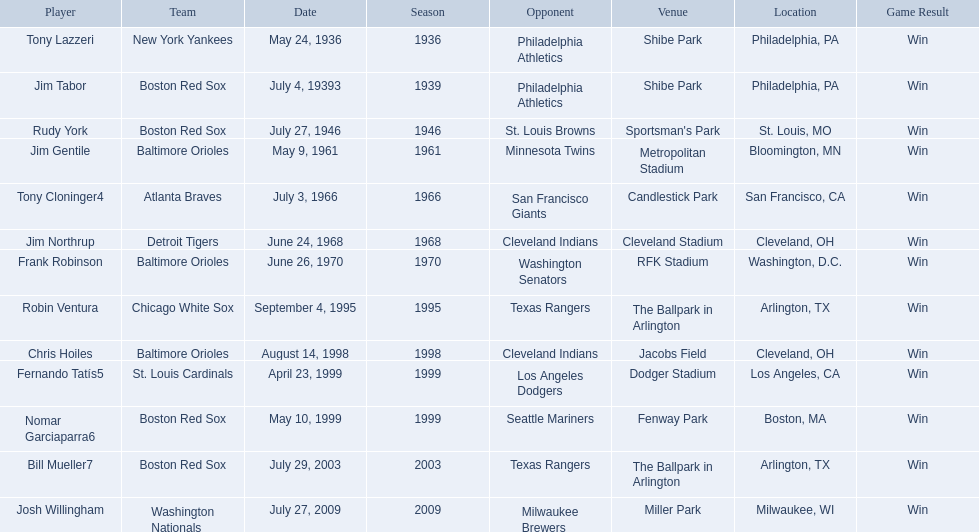Which teams played between the years 1960 and 1970? Baltimore Orioles, Atlanta Braves, Detroit Tigers, Baltimore Orioles. Of these teams that played, which ones played against the cleveland indians? Detroit Tigers. On what day did these two teams play? June 24, 1968. 